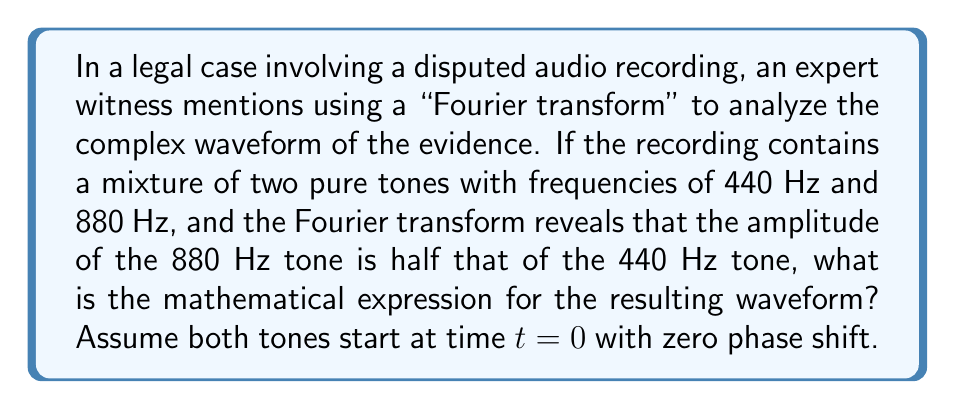Help me with this question. To understand this problem, we'll break it down into steps:

1) A pure tone can be represented mathematically as a sine wave:
   $A \sin(2\pi ft)$
   where $A$ is the amplitude, $f$ is the frequency, and $t$ is time.

2) We have two tones:
   - 440 Hz with amplitude $A$
   - 880 Hz with amplitude $A/2$ (half of the 440 Hz tone)

3) The mathematical expressions for these tones are:
   - 440 Hz: $A \sin(2\pi \cdot 440t)$
   - 880 Hz: $\frac{A}{2} \sin(2\pi \cdot 880t)$

4) The resulting waveform is the sum of these two tones:

   $y(t) = A \sin(2\pi \cdot 440t) + \frac{A}{2} \sin(2\pi \cdot 880t)$

5) We can simplify this by factoring out $A$:

   $y(t) = A[\sin(2\pi \cdot 440t) + \frac{1}{2} \sin(2\pi \cdot 880t)]$

This expression represents the complex waveform that combines both tones.
Answer: $y(t) = A[\sin(2\pi \cdot 440t) + \frac{1}{2} \sin(2\pi \cdot 880t)]$ 